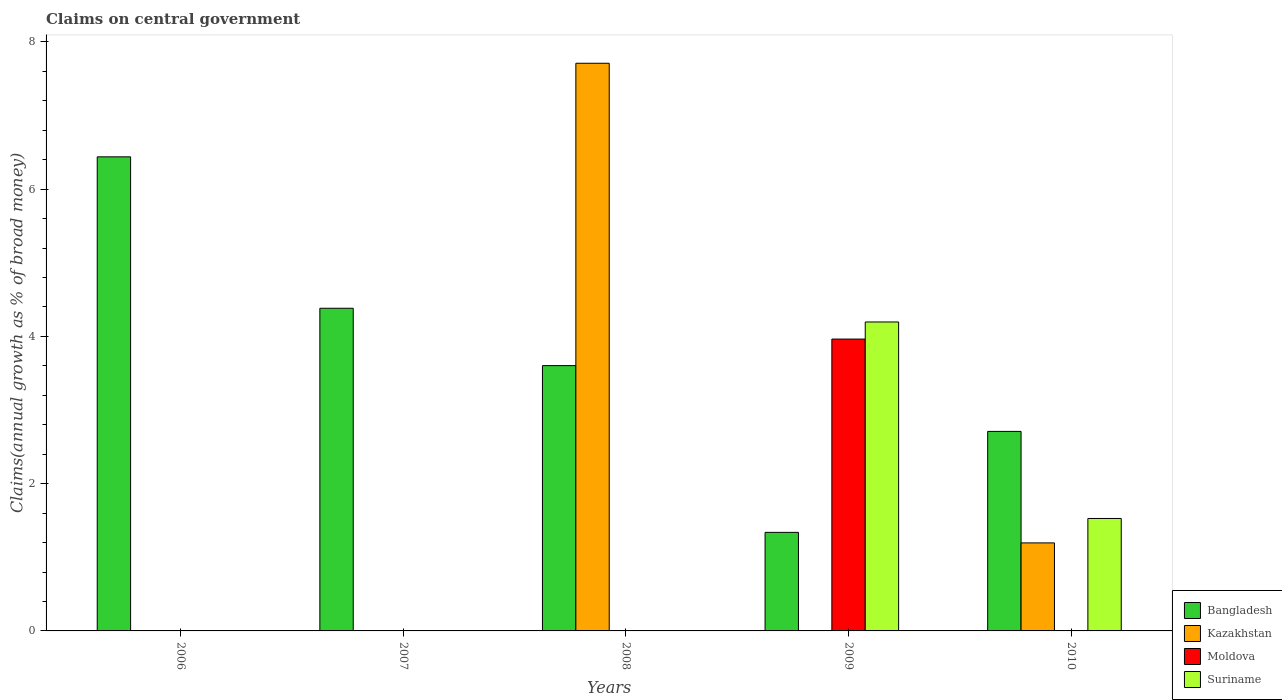How many different coloured bars are there?
Your response must be concise. 4. Are the number of bars per tick equal to the number of legend labels?
Offer a very short reply. No. Are the number of bars on each tick of the X-axis equal?
Ensure brevity in your answer.  No. How many bars are there on the 1st tick from the left?
Provide a short and direct response. 1. How many bars are there on the 5th tick from the right?
Give a very brief answer. 1. What is the label of the 1st group of bars from the left?
Keep it short and to the point. 2006. What is the percentage of broad money claimed on centeral government in Bangladesh in 2006?
Your response must be concise. 6.44. Across all years, what is the maximum percentage of broad money claimed on centeral government in Moldova?
Give a very brief answer. 3.96. In which year was the percentage of broad money claimed on centeral government in Suriname maximum?
Your answer should be compact. 2009. What is the total percentage of broad money claimed on centeral government in Suriname in the graph?
Provide a succinct answer. 5.72. What is the difference between the percentage of broad money claimed on centeral government in Bangladesh in 2007 and that in 2010?
Provide a short and direct response. 1.67. What is the difference between the percentage of broad money claimed on centeral government in Suriname in 2010 and the percentage of broad money claimed on centeral government in Bangladesh in 2009?
Make the answer very short. 0.19. What is the average percentage of broad money claimed on centeral government in Kazakhstan per year?
Your answer should be very brief. 1.78. In the year 2009, what is the difference between the percentage of broad money claimed on centeral government in Suriname and percentage of broad money claimed on centeral government in Moldova?
Offer a very short reply. 0.23. What is the ratio of the percentage of broad money claimed on centeral government in Bangladesh in 2008 to that in 2009?
Ensure brevity in your answer.  2.69. Is the percentage of broad money claimed on centeral government in Kazakhstan in 2008 less than that in 2010?
Provide a short and direct response. No. What is the difference between the highest and the second highest percentage of broad money claimed on centeral government in Bangladesh?
Your answer should be very brief. 2.06. What is the difference between the highest and the lowest percentage of broad money claimed on centeral government in Suriname?
Your response must be concise. 4.2. In how many years, is the percentage of broad money claimed on centeral government in Bangladesh greater than the average percentage of broad money claimed on centeral government in Bangladesh taken over all years?
Your answer should be very brief. 2. Is it the case that in every year, the sum of the percentage of broad money claimed on centeral government in Bangladesh and percentage of broad money claimed on centeral government in Moldova is greater than the sum of percentage of broad money claimed on centeral government in Suriname and percentage of broad money claimed on centeral government in Kazakhstan?
Provide a short and direct response. No. Are all the bars in the graph horizontal?
Ensure brevity in your answer.  No. How many years are there in the graph?
Your response must be concise. 5. What is the difference between two consecutive major ticks on the Y-axis?
Give a very brief answer. 2. How many legend labels are there?
Your answer should be compact. 4. How are the legend labels stacked?
Your answer should be compact. Vertical. What is the title of the graph?
Your response must be concise. Claims on central government. Does "Latvia" appear as one of the legend labels in the graph?
Keep it short and to the point. No. What is the label or title of the Y-axis?
Your answer should be compact. Claims(annual growth as % of broad money). What is the Claims(annual growth as % of broad money) of Bangladesh in 2006?
Make the answer very short. 6.44. What is the Claims(annual growth as % of broad money) in Kazakhstan in 2006?
Your answer should be compact. 0. What is the Claims(annual growth as % of broad money) of Moldova in 2006?
Provide a succinct answer. 0. What is the Claims(annual growth as % of broad money) of Bangladesh in 2007?
Your answer should be very brief. 4.38. What is the Claims(annual growth as % of broad money) of Moldova in 2007?
Offer a very short reply. 0. What is the Claims(annual growth as % of broad money) of Suriname in 2007?
Give a very brief answer. 0. What is the Claims(annual growth as % of broad money) in Bangladesh in 2008?
Your answer should be very brief. 3.6. What is the Claims(annual growth as % of broad money) in Kazakhstan in 2008?
Keep it short and to the point. 7.71. What is the Claims(annual growth as % of broad money) in Suriname in 2008?
Keep it short and to the point. 0. What is the Claims(annual growth as % of broad money) in Bangladesh in 2009?
Offer a terse response. 1.34. What is the Claims(annual growth as % of broad money) of Moldova in 2009?
Offer a very short reply. 3.96. What is the Claims(annual growth as % of broad money) of Suriname in 2009?
Your answer should be very brief. 4.2. What is the Claims(annual growth as % of broad money) of Bangladesh in 2010?
Give a very brief answer. 2.71. What is the Claims(annual growth as % of broad money) in Kazakhstan in 2010?
Offer a very short reply. 1.2. What is the Claims(annual growth as % of broad money) in Suriname in 2010?
Your answer should be very brief. 1.53. Across all years, what is the maximum Claims(annual growth as % of broad money) of Bangladesh?
Offer a very short reply. 6.44. Across all years, what is the maximum Claims(annual growth as % of broad money) of Kazakhstan?
Your answer should be compact. 7.71. Across all years, what is the maximum Claims(annual growth as % of broad money) of Moldova?
Keep it short and to the point. 3.96. Across all years, what is the maximum Claims(annual growth as % of broad money) of Suriname?
Provide a short and direct response. 4.2. Across all years, what is the minimum Claims(annual growth as % of broad money) in Bangladesh?
Provide a short and direct response. 1.34. What is the total Claims(annual growth as % of broad money) in Bangladesh in the graph?
Keep it short and to the point. 18.47. What is the total Claims(annual growth as % of broad money) of Kazakhstan in the graph?
Make the answer very short. 8.91. What is the total Claims(annual growth as % of broad money) in Moldova in the graph?
Your answer should be very brief. 3.96. What is the total Claims(annual growth as % of broad money) in Suriname in the graph?
Make the answer very short. 5.72. What is the difference between the Claims(annual growth as % of broad money) in Bangladesh in 2006 and that in 2007?
Offer a terse response. 2.06. What is the difference between the Claims(annual growth as % of broad money) of Bangladesh in 2006 and that in 2008?
Your response must be concise. 2.84. What is the difference between the Claims(annual growth as % of broad money) of Bangladesh in 2006 and that in 2009?
Your answer should be very brief. 5.1. What is the difference between the Claims(annual growth as % of broad money) in Bangladesh in 2006 and that in 2010?
Make the answer very short. 3.73. What is the difference between the Claims(annual growth as % of broad money) in Bangladesh in 2007 and that in 2008?
Your response must be concise. 0.78. What is the difference between the Claims(annual growth as % of broad money) of Bangladesh in 2007 and that in 2009?
Your answer should be very brief. 3.04. What is the difference between the Claims(annual growth as % of broad money) in Bangladesh in 2007 and that in 2010?
Your answer should be compact. 1.67. What is the difference between the Claims(annual growth as % of broad money) of Bangladesh in 2008 and that in 2009?
Provide a short and direct response. 2.26. What is the difference between the Claims(annual growth as % of broad money) of Bangladesh in 2008 and that in 2010?
Ensure brevity in your answer.  0.89. What is the difference between the Claims(annual growth as % of broad money) in Kazakhstan in 2008 and that in 2010?
Your answer should be very brief. 6.51. What is the difference between the Claims(annual growth as % of broad money) in Bangladesh in 2009 and that in 2010?
Your response must be concise. -1.37. What is the difference between the Claims(annual growth as % of broad money) of Suriname in 2009 and that in 2010?
Offer a terse response. 2.67. What is the difference between the Claims(annual growth as % of broad money) in Bangladesh in 2006 and the Claims(annual growth as % of broad money) in Kazakhstan in 2008?
Give a very brief answer. -1.27. What is the difference between the Claims(annual growth as % of broad money) in Bangladesh in 2006 and the Claims(annual growth as % of broad money) in Moldova in 2009?
Make the answer very short. 2.48. What is the difference between the Claims(annual growth as % of broad money) of Bangladesh in 2006 and the Claims(annual growth as % of broad money) of Suriname in 2009?
Your response must be concise. 2.24. What is the difference between the Claims(annual growth as % of broad money) in Bangladesh in 2006 and the Claims(annual growth as % of broad money) in Kazakhstan in 2010?
Give a very brief answer. 5.24. What is the difference between the Claims(annual growth as % of broad money) in Bangladesh in 2006 and the Claims(annual growth as % of broad money) in Suriname in 2010?
Your answer should be very brief. 4.91. What is the difference between the Claims(annual growth as % of broad money) in Bangladesh in 2007 and the Claims(annual growth as % of broad money) in Kazakhstan in 2008?
Provide a short and direct response. -3.33. What is the difference between the Claims(annual growth as % of broad money) in Bangladesh in 2007 and the Claims(annual growth as % of broad money) in Moldova in 2009?
Your answer should be very brief. 0.42. What is the difference between the Claims(annual growth as % of broad money) of Bangladesh in 2007 and the Claims(annual growth as % of broad money) of Suriname in 2009?
Your answer should be very brief. 0.19. What is the difference between the Claims(annual growth as % of broad money) of Bangladesh in 2007 and the Claims(annual growth as % of broad money) of Kazakhstan in 2010?
Provide a succinct answer. 3.19. What is the difference between the Claims(annual growth as % of broad money) in Bangladesh in 2007 and the Claims(annual growth as % of broad money) in Suriname in 2010?
Your answer should be compact. 2.86. What is the difference between the Claims(annual growth as % of broad money) of Bangladesh in 2008 and the Claims(annual growth as % of broad money) of Moldova in 2009?
Give a very brief answer. -0.36. What is the difference between the Claims(annual growth as % of broad money) of Bangladesh in 2008 and the Claims(annual growth as % of broad money) of Suriname in 2009?
Your answer should be very brief. -0.59. What is the difference between the Claims(annual growth as % of broad money) of Kazakhstan in 2008 and the Claims(annual growth as % of broad money) of Moldova in 2009?
Offer a terse response. 3.75. What is the difference between the Claims(annual growth as % of broad money) in Kazakhstan in 2008 and the Claims(annual growth as % of broad money) in Suriname in 2009?
Your answer should be compact. 3.51. What is the difference between the Claims(annual growth as % of broad money) in Bangladesh in 2008 and the Claims(annual growth as % of broad money) in Kazakhstan in 2010?
Make the answer very short. 2.41. What is the difference between the Claims(annual growth as % of broad money) of Bangladesh in 2008 and the Claims(annual growth as % of broad money) of Suriname in 2010?
Your response must be concise. 2.08. What is the difference between the Claims(annual growth as % of broad money) in Kazakhstan in 2008 and the Claims(annual growth as % of broad money) in Suriname in 2010?
Provide a short and direct response. 6.18. What is the difference between the Claims(annual growth as % of broad money) of Bangladesh in 2009 and the Claims(annual growth as % of broad money) of Kazakhstan in 2010?
Your answer should be compact. 0.14. What is the difference between the Claims(annual growth as % of broad money) of Bangladesh in 2009 and the Claims(annual growth as % of broad money) of Suriname in 2010?
Keep it short and to the point. -0.19. What is the difference between the Claims(annual growth as % of broad money) of Moldova in 2009 and the Claims(annual growth as % of broad money) of Suriname in 2010?
Make the answer very short. 2.44. What is the average Claims(annual growth as % of broad money) in Bangladesh per year?
Offer a terse response. 3.69. What is the average Claims(annual growth as % of broad money) in Kazakhstan per year?
Make the answer very short. 1.78. What is the average Claims(annual growth as % of broad money) in Moldova per year?
Give a very brief answer. 0.79. What is the average Claims(annual growth as % of broad money) in Suriname per year?
Offer a very short reply. 1.14. In the year 2008, what is the difference between the Claims(annual growth as % of broad money) of Bangladesh and Claims(annual growth as % of broad money) of Kazakhstan?
Provide a succinct answer. -4.11. In the year 2009, what is the difference between the Claims(annual growth as % of broad money) in Bangladesh and Claims(annual growth as % of broad money) in Moldova?
Offer a very short reply. -2.63. In the year 2009, what is the difference between the Claims(annual growth as % of broad money) in Bangladesh and Claims(annual growth as % of broad money) in Suriname?
Make the answer very short. -2.86. In the year 2009, what is the difference between the Claims(annual growth as % of broad money) in Moldova and Claims(annual growth as % of broad money) in Suriname?
Offer a very short reply. -0.23. In the year 2010, what is the difference between the Claims(annual growth as % of broad money) in Bangladesh and Claims(annual growth as % of broad money) in Kazakhstan?
Provide a succinct answer. 1.51. In the year 2010, what is the difference between the Claims(annual growth as % of broad money) in Bangladesh and Claims(annual growth as % of broad money) in Suriname?
Offer a terse response. 1.18. In the year 2010, what is the difference between the Claims(annual growth as % of broad money) of Kazakhstan and Claims(annual growth as % of broad money) of Suriname?
Ensure brevity in your answer.  -0.33. What is the ratio of the Claims(annual growth as % of broad money) of Bangladesh in 2006 to that in 2007?
Give a very brief answer. 1.47. What is the ratio of the Claims(annual growth as % of broad money) in Bangladesh in 2006 to that in 2008?
Provide a short and direct response. 1.79. What is the ratio of the Claims(annual growth as % of broad money) in Bangladesh in 2006 to that in 2009?
Make the answer very short. 4.81. What is the ratio of the Claims(annual growth as % of broad money) in Bangladesh in 2006 to that in 2010?
Offer a terse response. 2.38. What is the ratio of the Claims(annual growth as % of broad money) in Bangladesh in 2007 to that in 2008?
Your answer should be compact. 1.22. What is the ratio of the Claims(annual growth as % of broad money) of Bangladesh in 2007 to that in 2009?
Give a very brief answer. 3.27. What is the ratio of the Claims(annual growth as % of broad money) of Bangladesh in 2007 to that in 2010?
Your answer should be compact. 1.62. What is the ratio of the Claims(annual growth as % of broad money) in Bangladesh in 2008 to that in 2009?
Your answer should be very brief. 2.69. What is the ratio of the Claims(annual growth as % of broad money) in Bangladesh in 2008 to that in 2010?
Offer a very short reply. 1.33. What is the ratio of the Claims(annual growth as % of broad money) in Kazakhstan in 2008 to that in 2010?
Provide a succinct answer. 6.45. What is the ratio of the Claims(annual growth as % of broad money) in Bangladesh in 2009 to that in 2010?
Your answer should be compact. 0.49. What is the ratio of the Claims(annual growth as % of broad money) of Suriname in 2009 to that in 2010?
Your response must be concise. 2.75. What is the difference between the highest and the second highest Claims(annual growth as % of broad money) of Bangladesh?
Your answer should be compact. 2.06. What is the difference between the highest and the lowest Claims(annual growth as % of broad money) of Bangladesh?
Offer a very short reply. 5.1. What is the difference between the highest and the lowest Claims(annual growth as % of broad money) in Kazakhstan?
Your answer should be very brief. 7.71. What is the difference between the highest and the lowest Claims(annual growth as % of broad money) in Moldova?
Give a very brief answer. 3.96. What is the difference between the highest and the lowest Claims(annual growth as % of broad money) in Suriname?
Offer a very short reply. 4.2. 